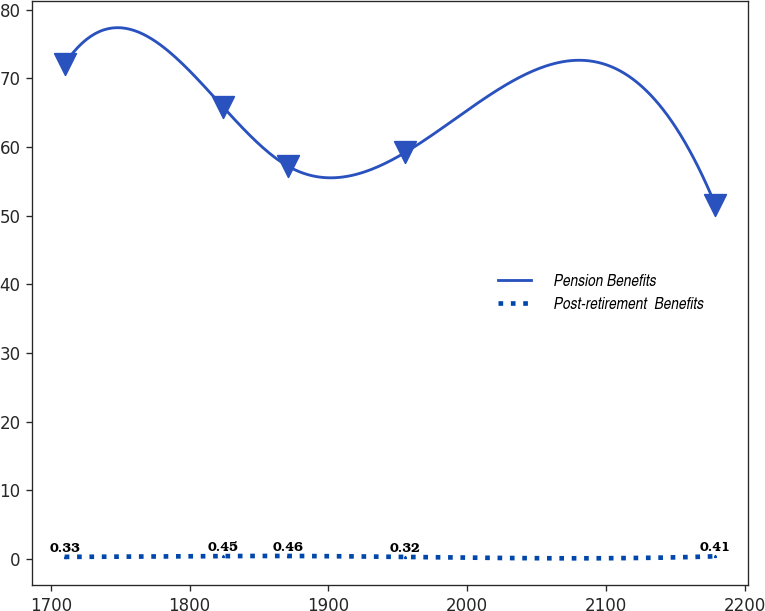<chart> <loc_0><loc_0><loc_500><loc_500><line_chart><ecel><fcel>Pension Benefits<fcel>Post-retirement  Benefits<nl><fcel>1709.92<fcel>72.14<fcel>0.33<nl><fcel>1824.28<fcel>65.81<fcel>0.45<nl><fcel>1871.19<fcel>57.19<fcel>0.46<nl><fcel>1955.53<fcel>59.25<fcel>0.32<nl><fcel>2179<fcel>51.55<fcel>0.41<nl></chart> 